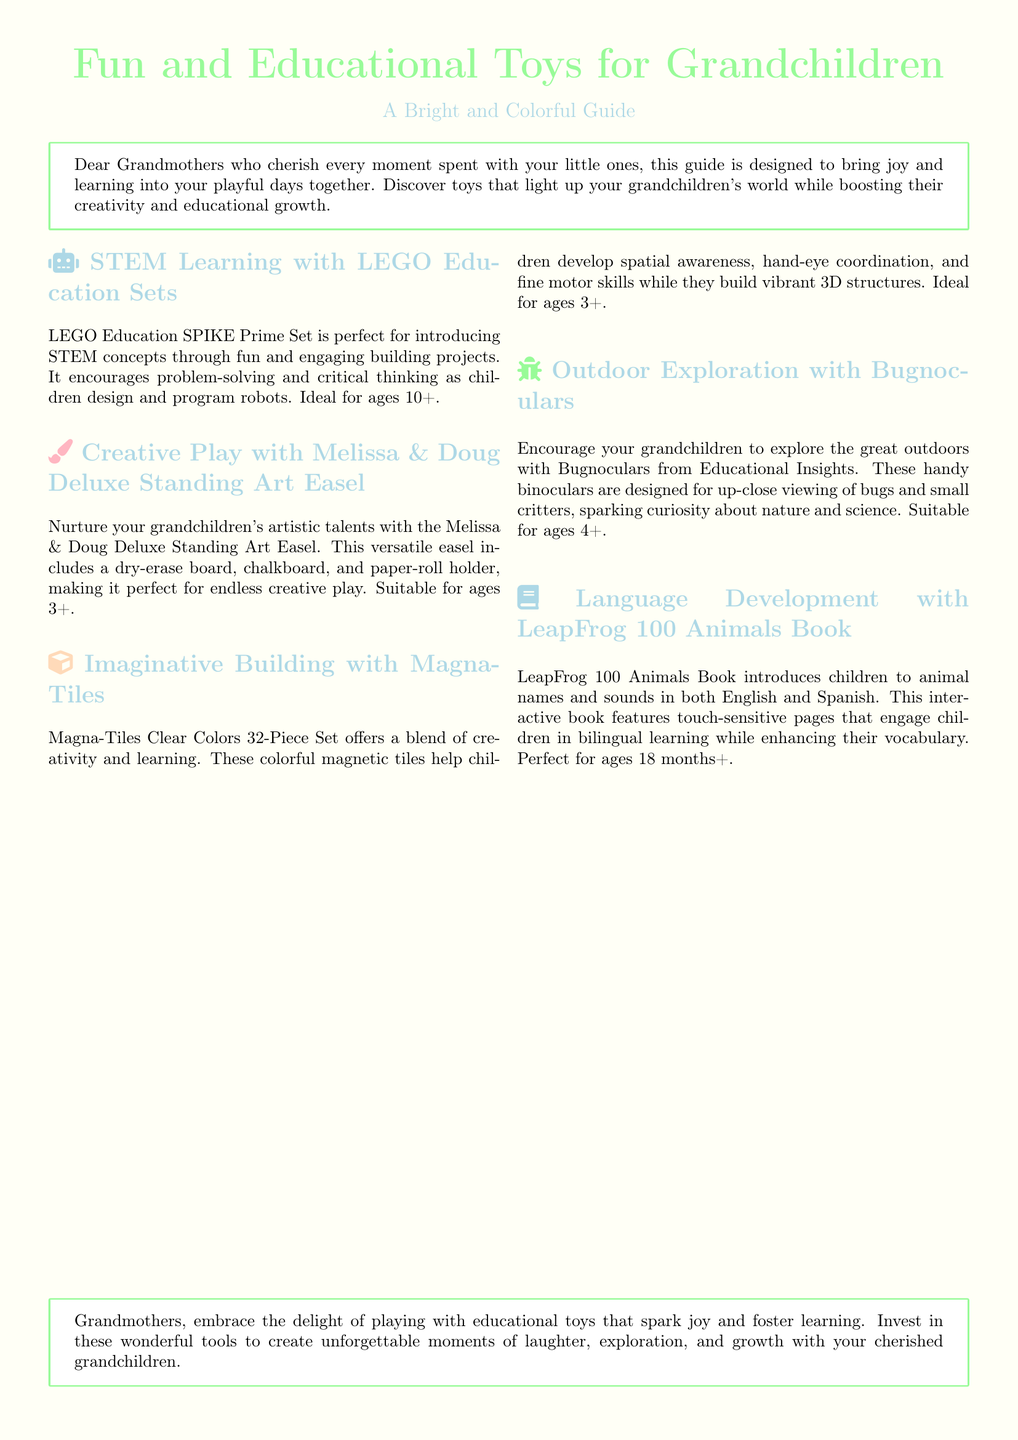What is the title of the guide? The title of the guide is explicitly stated at the top of the document.
Answer: Fun and Educational Toys for Grandchildren What age group is the LEGO Education SPIKE Prime Set suitable for? The document specifies the age group for this product in its description.
Answer: 10+ What toy helps develop spatial awareness? The document mentions which toy aids in developing this skill.
Answer: Magna-Tiles What is the primary language focus of the LeapFrog 100 Animals Book? The document describes the language features of the book, highlighting bilingual learning.
Answer: English and Spanish What type of play does the Melissa & Doug Deluxe Standing Art Easel promote? The description of the toy indicates its purpose related to children’s skills.
Answer: Creative play What do Bugnoculars encourage children to do? The document explains the intended use of Bugnoculars in relation to children's activities.
Answer: Explore the outdoors What color is the background of the document? The document specifies the color used for the page background.
Answer: Pastel yellow Which toy features touch-sensitive pages? This information is provided in the description of a specific educational toy.
Answer: LeapFrog 100 Animals Book 